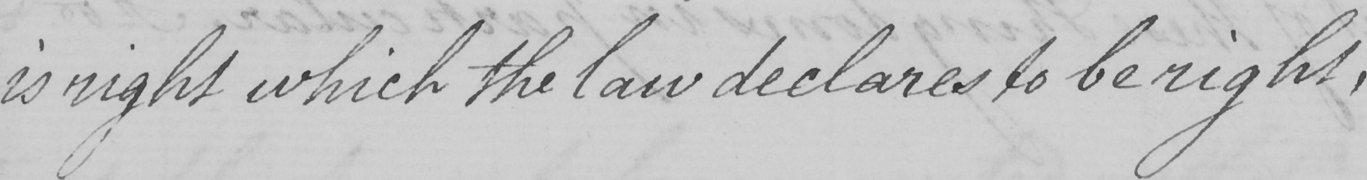Can you tell me what this handwritten text says? is right which the law declares to be right, 